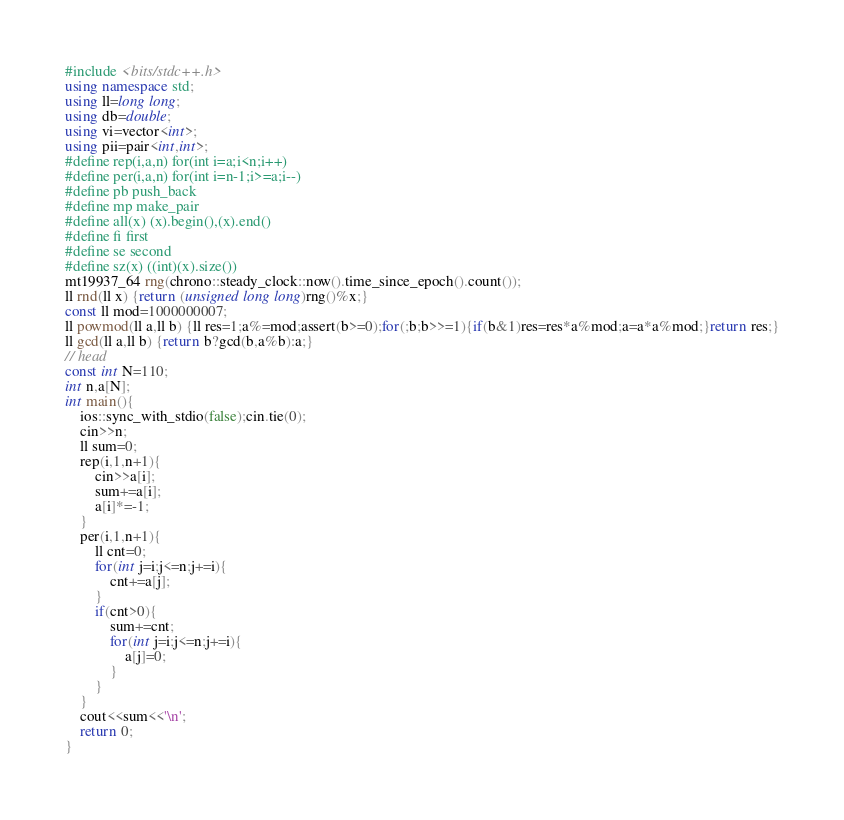Convert code to text. <code><loc_0><loc_0><loc_500><loc_500><_C++_>#include <bits/stdc++.h>
using namespace std;
using ll=long long;
using db=double;
using vi=vector<int>;
using pii=pair<int,int>;
#define rep(i,a,n) for(int i=a;i<n;i++)
#define per(i,a,n) for(int i=n-1;i>=a;i--)
#define pb push_back
#define mp make_pair
#define all(x) (x).begin(),(x).end()
#define fi first
#define se second
#define sz(x) ((int)(x).size())
mt19937_64 rng(chrono::steady_clock::now().time_since_epoch().count());
ll rnd(ll x) {return (unsigned long long)rng()%x;}
const ll mod=1000000007;
ll powmod(ll a,ll b) {ll res=1;a%=mod;assert(b>=0);for(;b;b>>=1){if(b&1)res=res*a%mod;a=a*a%mod;}return res;}
ll gcd(ll a,ll b) {return b?gcd(b,a%b):a;}
// head
const int N=110;
int n,a[N];
int main(){
	ios::sync_with_stdio(false);cin.tie(0);
	cin>>n;
	ll sum=0;
	rep(i,1,n+1){
		cin>>a[i];
		sum+=a[i];
		a[i]*=-1;
	}
	per(i,1,n+1){
		ll cnt=0;
		for(int j=i;j<=n;j+=i){
			cnt+=a[j];
		}
		if(cnt>0){
			sum+=cnt;
			for(int j=i;j<=n;j+=i){
				a[j]=0;
			}
		}
	}
	cout<<sum<<'\n';
	return 0;
}</code> 